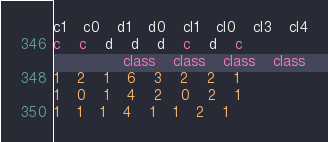<code> <loc_0><loc_0><loc_500><loc_500><_SQL_>c1	c0	d1	d0	cl1	cl0	cl3	cl4
c	c	d	d	d	c	d	c
				class	class	class	class
1	2	1	6	3	2	2	1
1	0	1	4	2	0	2	1
1	1	1	4	1	1	2	1
</code> 